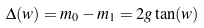<formula> <loc_0><loc_0><loc_500><loc_500>\Delta ( w ) = m _ { 0 } - m _ { 1 } = 2 g \tan ( w )</formula> 